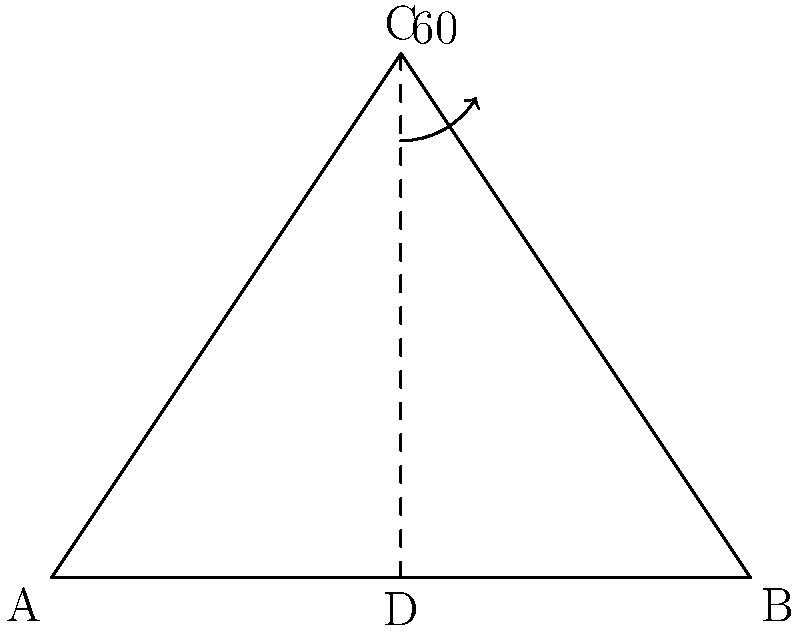In the Balinese Kecak dance, performers often form a triangular formation. If the angle at the apex of this triangle is 60°, and the base of the triangle is 4 meters wide, what is the height of this triangular formation to the nearest tenth of a meter? Let's approach this step-by-step:

1) We have an isosceles triangle where the apex angle is 60°. Let's call the apex C and the base corners A and B.

2) Since the base is 4 meters, AB = 4m.

3) We need to find the height of the triangle, which is the perpendicular line from C to the midpoint of AB. Let's call this midpoint D.

4) In the right triangle CD:
   - The angle at C is 30° (half of 60°)
   - CD is the height we're looking for
   - AD is half of AB, so AD = 2m

5) We can use the tangent function to find CD:

   $\tan 30° = \frac{CD}{AD}$

6) Rearranging this:

   $CD = AD \times \tan 30°$

7) We know that $\tan 30° = \frac{1}{\sqrt{3}}$, so:

   $CD = 2 \times \frac{1}{\sqrt{3}} = \frac{2}{\sqrt{3}}$

8) To simplify this:
   $\frac{2}{\sqrt{3}} = \frac{2}{\sqrt{3}} \times \frac{\sqrt{3}}{\sqrt{3}} = \frac{2\sqrt{3}}{3} \approx 1.155$

9) Rounding to the nearest tenth:

   CD ≈ 1.2 meters

Therefore, the height of the triangular formation is approximately 1.2 meters.
Answer: 1.2 meters 